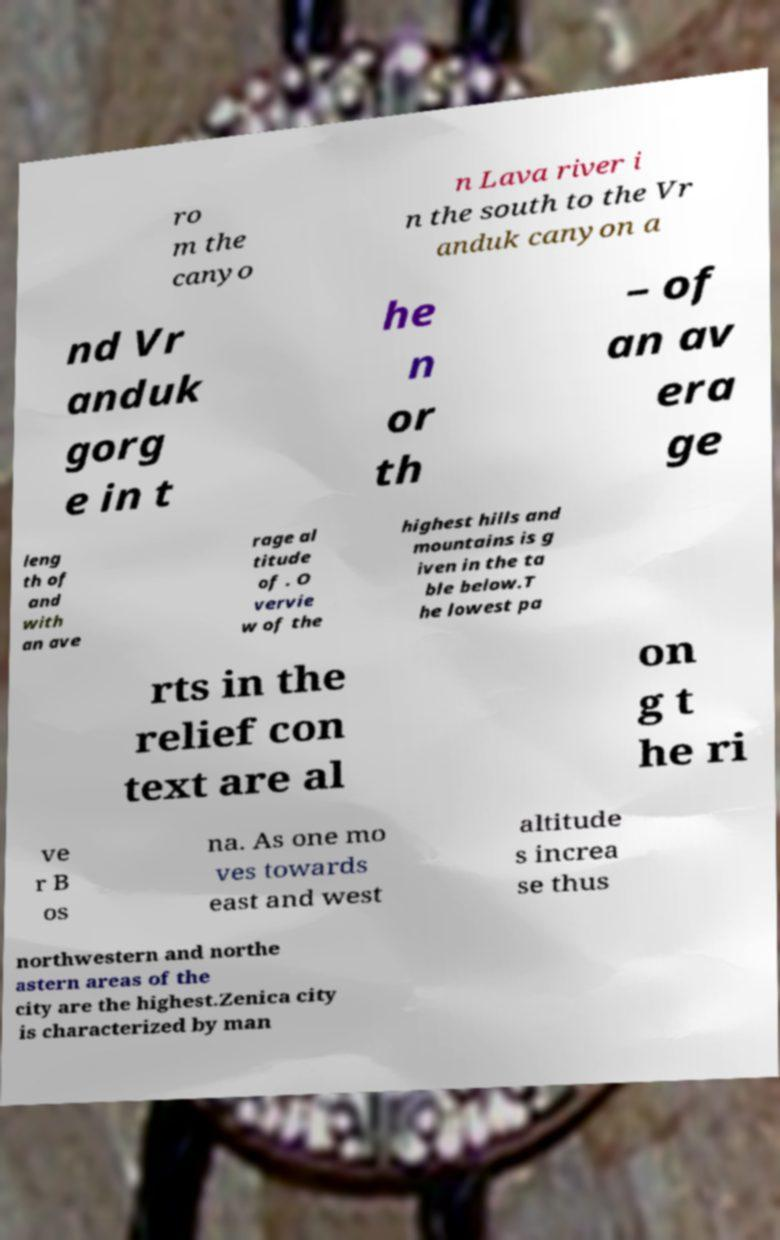Can you read and provide the text displayed in the image?This photo seems to have some interesting text. Can you extract and type it out for me? ro m the canyo n Lava river i n the south to the Vr anduk canyon a nd Vr anduk gorg e in t he n or th – of an av era ge leng th of and with an ave rage al titude of . O vervie w of the highest hills and mountains is g iven in the ta ble below.T he lowest pa rts in the relief con text are al on g t he ri ve r B os na. As one mo ves towards east and west altitude s increa se thus northwestern and northe astern areas of the city are the highest.Zenica city is characterized by man 